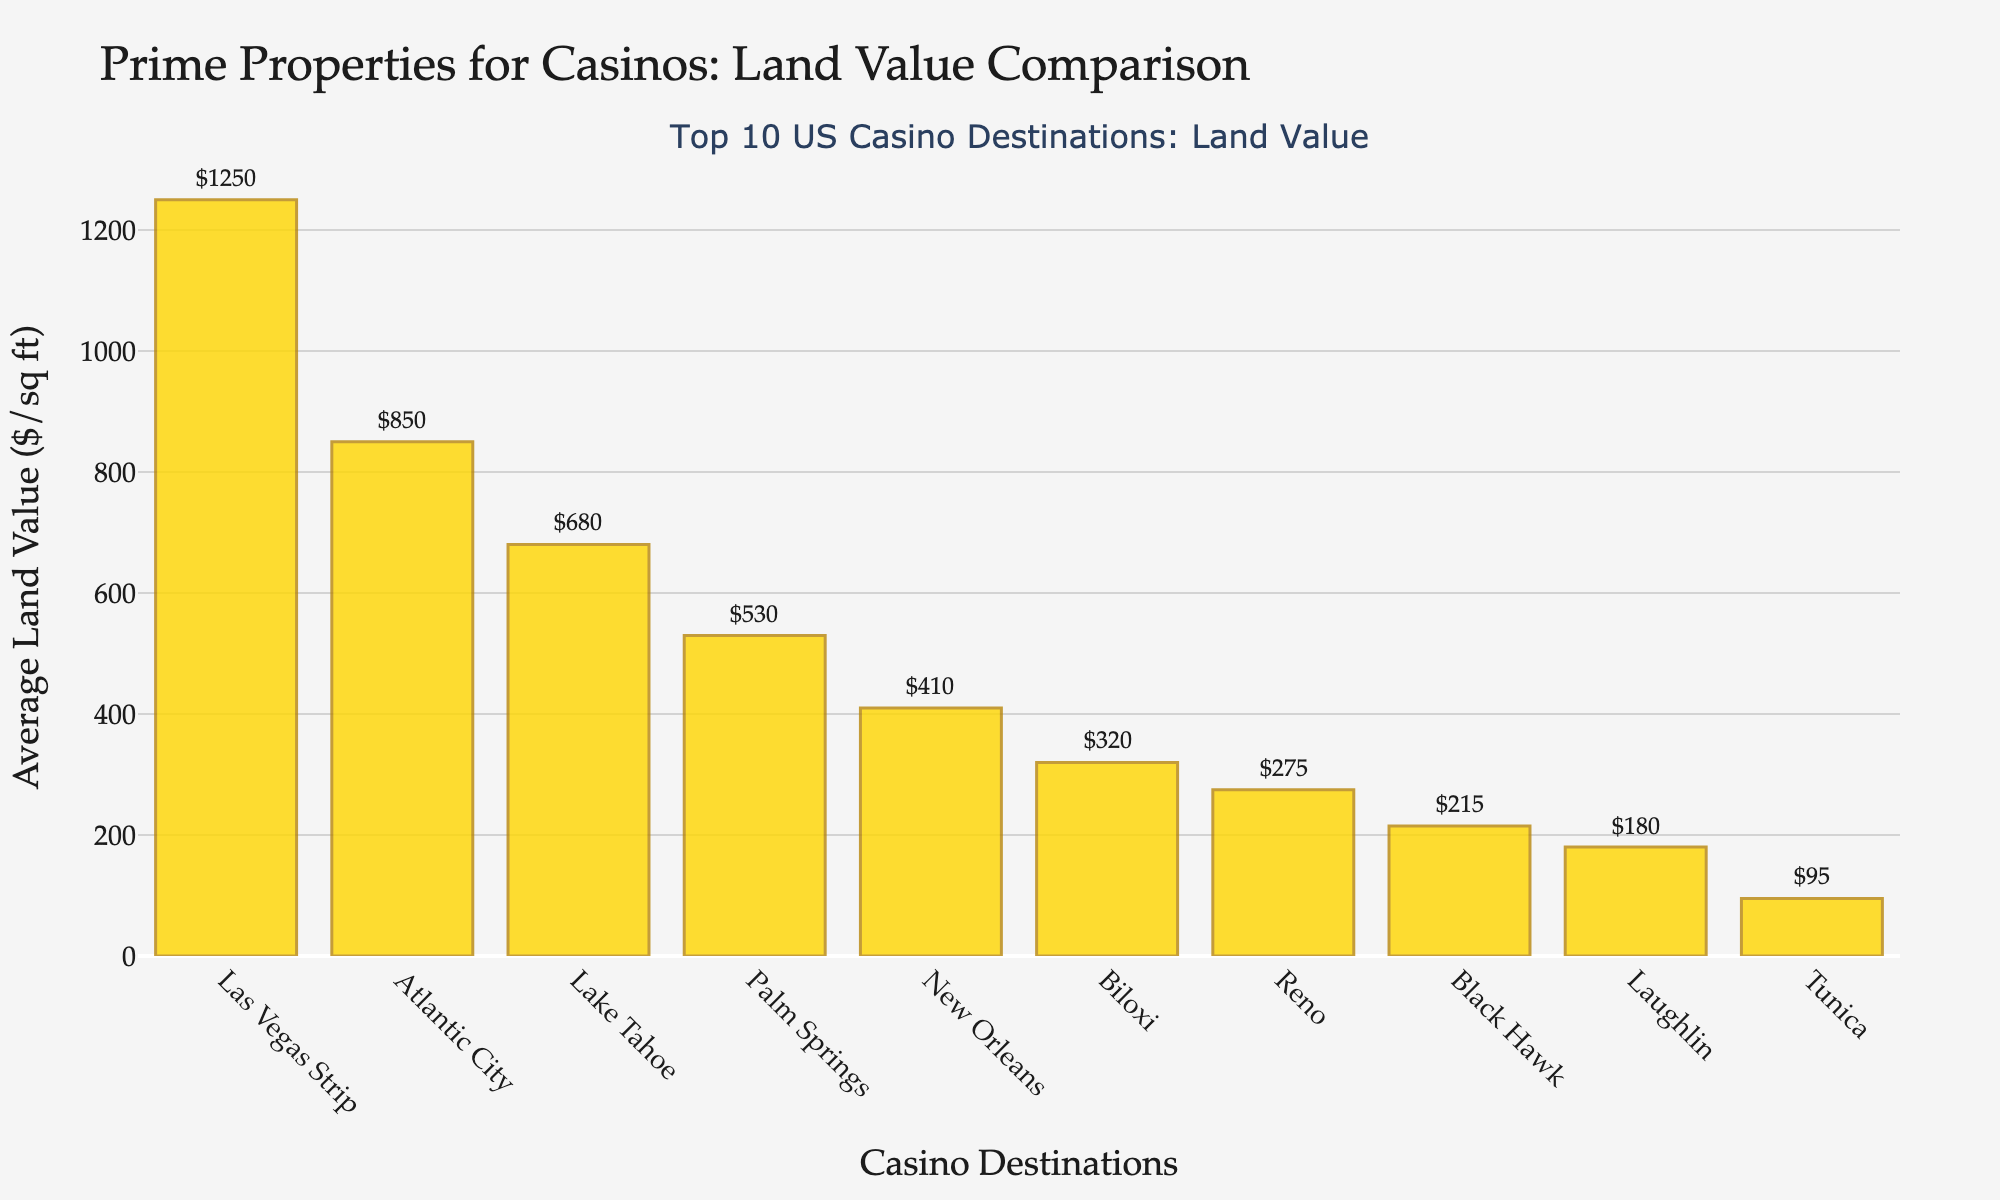What is the average land value per square foot for the top 10 casino destinations? Sum all the average land values: 1250 (Las Vegas Strip) + 850 (Atlantic City) + 320 (Biloxi) + 275 (Reno) + 410 (New Orleans) + 680 (Lake Tahoe) + 95 (Tunica) + 215 (Black Hawk) + 530 (Palm Springs) + 180 (Laughlin) = 4805. Then divide by the number of destinations (10): 4805 / 10 = 480.5
Answer: 480.5 Which casino destination has the highest average land value per square foot? The tallest bar represents Las Vegas Strip, with a value of $1250 per square foot, the highest among all the locations.
Answer: Las Vegas Strip What is the difference in average land value between Las Vegas Strip and Biloxi? The average land value for Las Vegas Strip is $1250 per square foot, and for Biloxi, it is $320 per square foot. The difference is 1250 - 320 = 930.
Answer: 930 What is the median average land value per square foot for these casino destinations? Arrange the values in ascending order: 95, 180, 215, 275, 320, 410, 530, 680, 850, 1250. The median is the average of the 5th and 6th values, which are 320 and 410. (320 + 410) / 2 = 365.
Answer: 365 Which casino destinations have an average land value greater than $500 per square foot? The bars representing Las Vegas Strip ($1250), Atlantic City ($850), Lake Tahoe ($680), and Palm Springs ($530) are all above $500.
Answer: Las Vegas Strip, Atlantic City, Lake Tahoe, Palm Springs How much more is the land value in New Orleans compared to Tunica? The average land value in New Orleans is $410 per square foot, and in Tunica, it is $95 per square foot. The difference is 410 - 95 = 315.
Answer: 315 What is the total land value of Lake Tahoe and Laughlin combined? The average land value for Lake Tahoe is $680 per square foot, and for Laughlin, it is $180 per square foot. The total combined is 680 + 180 = 860.
Answer: 860 Which location is the second least expensive in terms of average land value per square foot? The second lowest bar is Black Hawk with an average land value of $215 per square foot, higher only than Tunica at $95 per square foot.
Answer: Black Hawk Compare the average land values of Reno and Palm Springs and state how much higher or lower one is than the other. The average land value for Reno is $275 per square foot, and for Palm Springs, it is $530 per square foot. Palm Springs is higher by 530 - 275 = 255.
Answer: 255 higher 